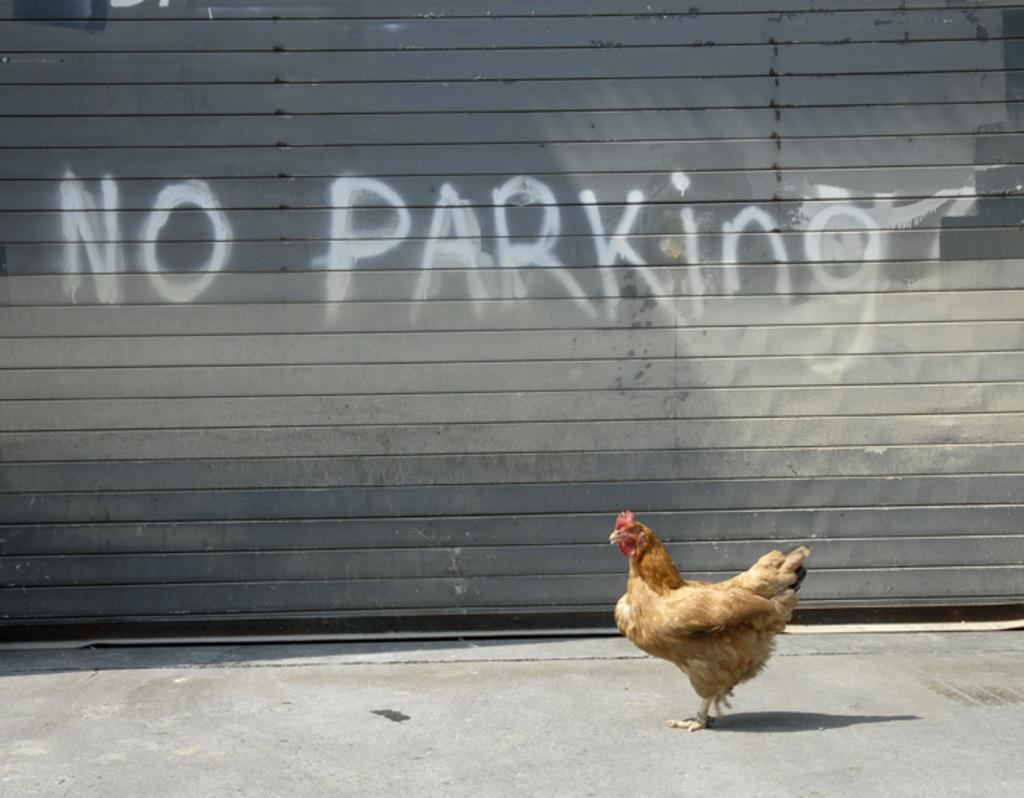What animal can be seen in the image? There is a hen in the image. What is the hen doing in the image? The hen is walking on the ground. What can be seen in the background of the image? There is a wall in the background of the image. Is there any text visible in the image? Yes, there is some text visible in the image. How far away is the clock from the hen in the image? There is no clock present in the image, so it is not possible to determine the distance between the hen and a clock. 